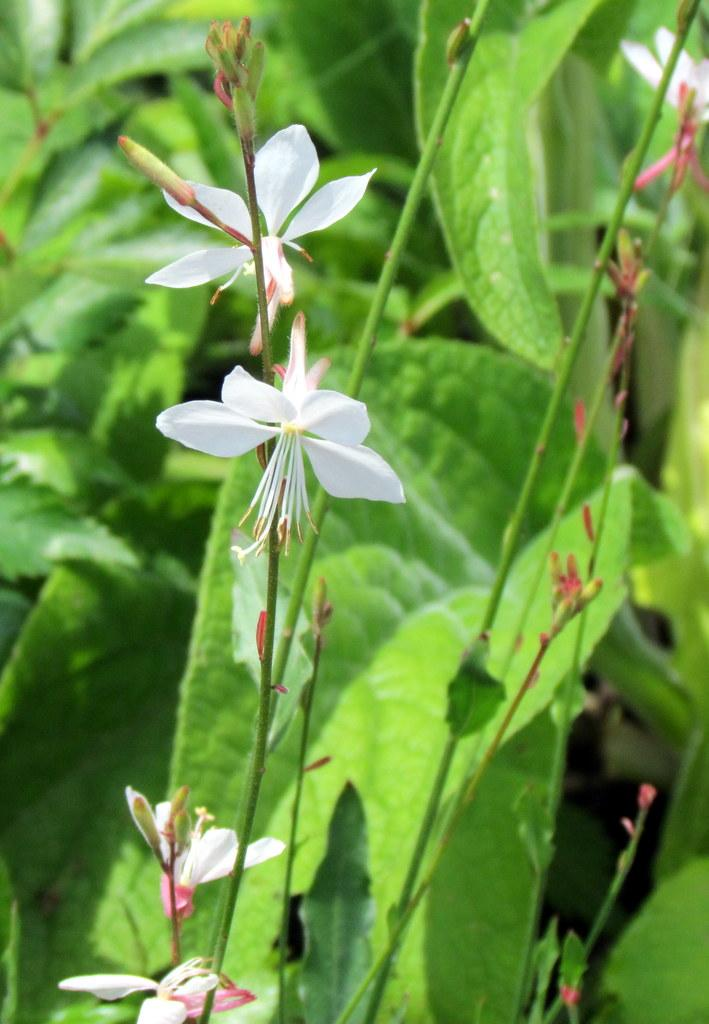What type of plant material can be seen in the image? There are leaves in the image. What type of flowers are present in the image? There are white color flowers in the image. What can be found on the flowers in the image? Pollen grains are visible in the image. What reward is being offered to the person who can find the hidden word in the image? There is no reward or hidden word present in the image; it features leaves and white flowers with visible pollen grains. 